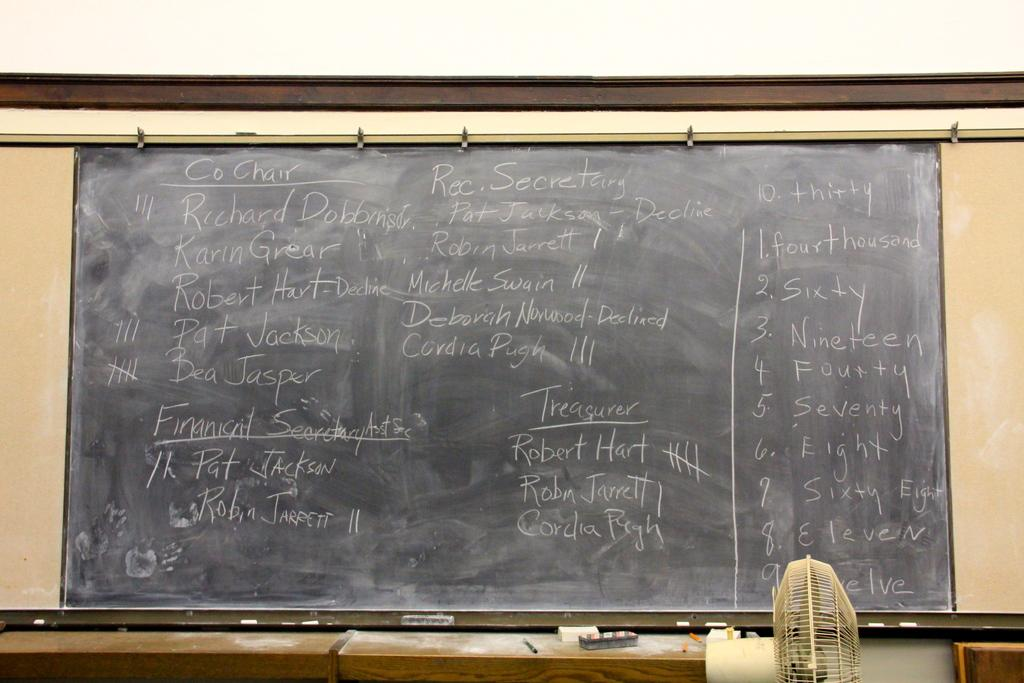What is the main object in the image with text on it? There is a blackboard with text written on it in the image. What type of device can be seen in the image for circulating air? There is a fan in the image. What type of furniture is present in the image? There are tables in the image. Can you describe any other objects in the image? There are some objects in the image, but their specific details are not mentioned in the provided facts. How does the visitor interact with the knowledge on the blackboard in the image? There is no visitor present in the image, so it is not possible to determine how they might interact with the knowledge on the blackboard. 